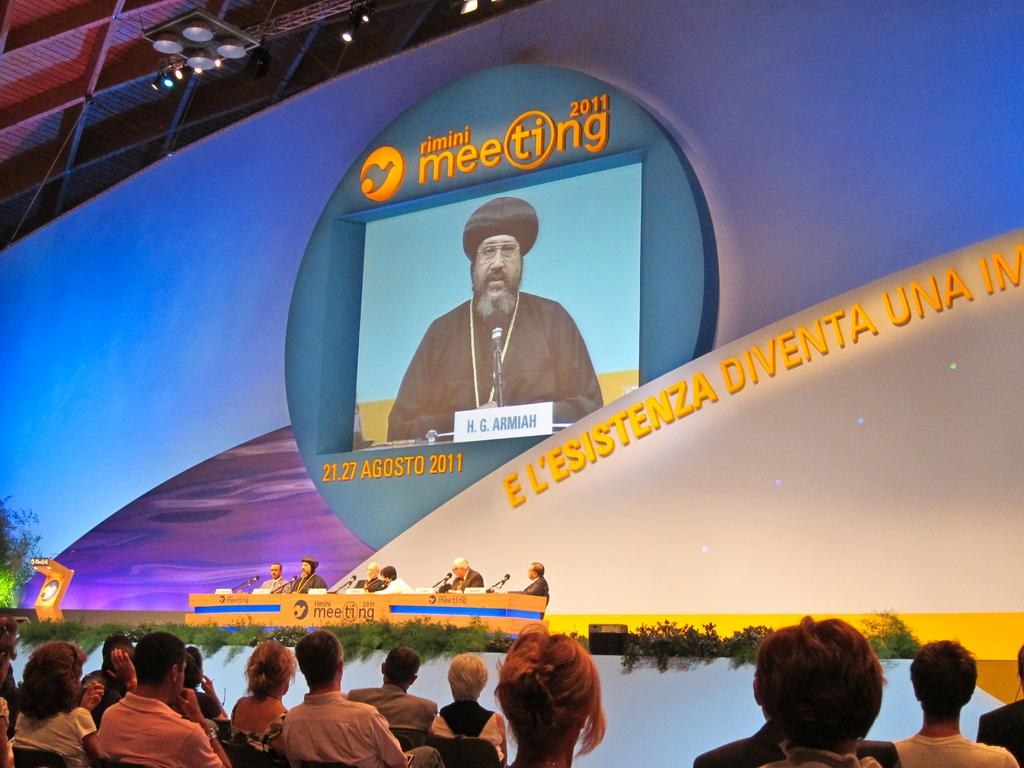<image>
Create a compact narrative representing the image presented. A large display on a wall displays the year 2011. 